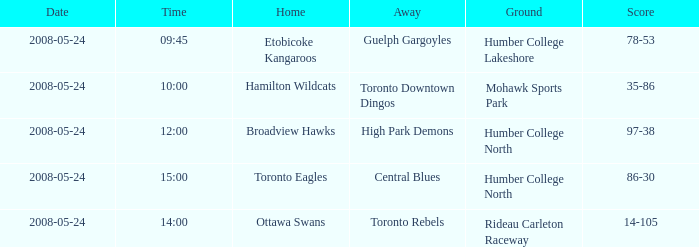On what day was the game that ended in a score of 97-38? 2008-05-24. 